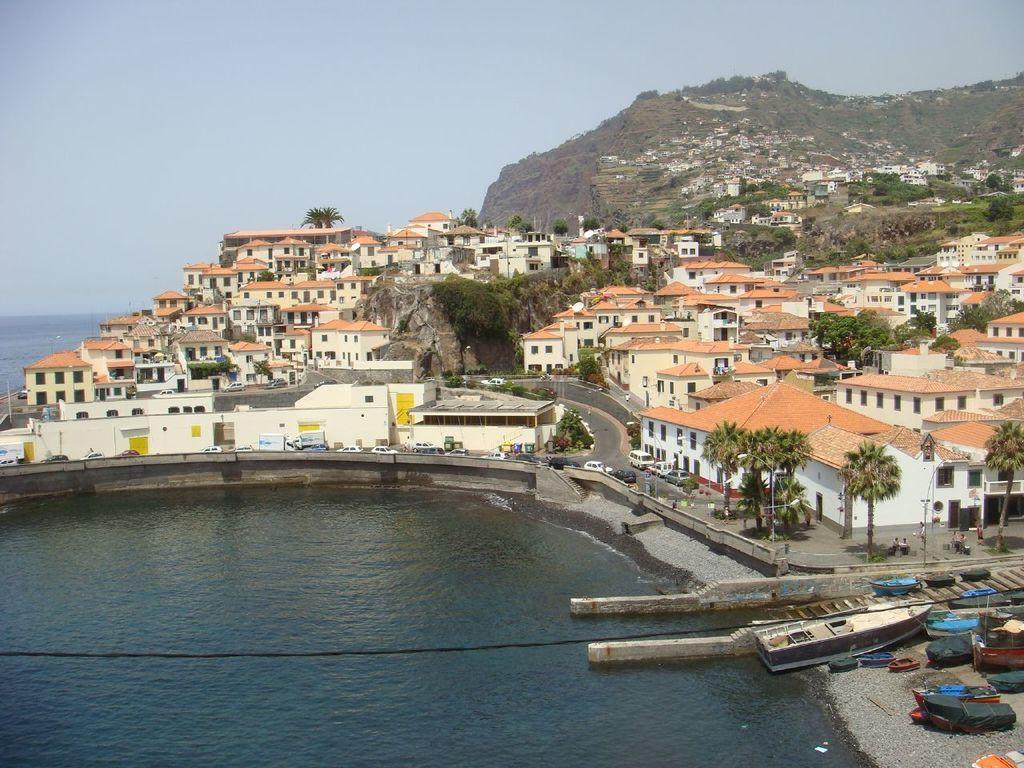Can you describe this image briefly? There are boats. Here we can see water, houses, trees, and vehicles. There are few persons. Here we can see a mountain. In the background there is sky. 